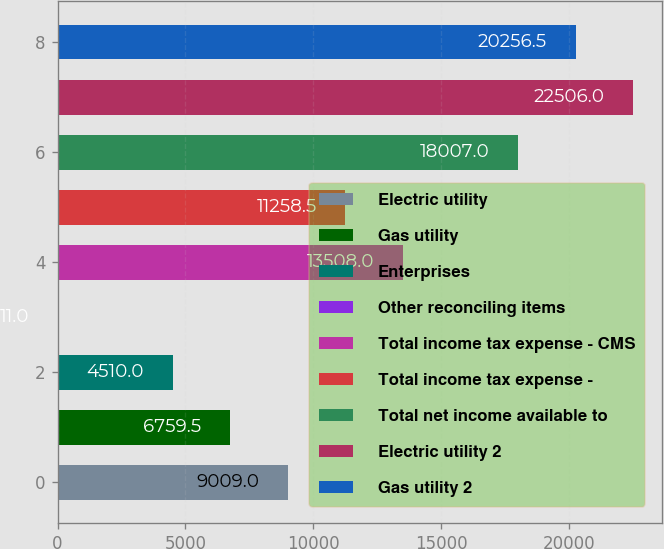Convert chart to OTSL. <chart><loc_0><loc_0><loc_500><loc_500><bar_chart><fcel>Electric utility<fcel>Gas utility<fcel>Enterprises<fcel>Other reconciling items<fcel>Total income tax expense - CMS<fcel>Total income tax expense -<fcel>Total net income available to<fcel>Electric utility 2<fcel>Gas utility 2<nl><fcel>9009<fcel>6759.5<fcel>4510<fcel>11<fcel>13508<fcel>11258.5<fcel>18007<fcel>22506<fcel>20256.5<nl></chart> 